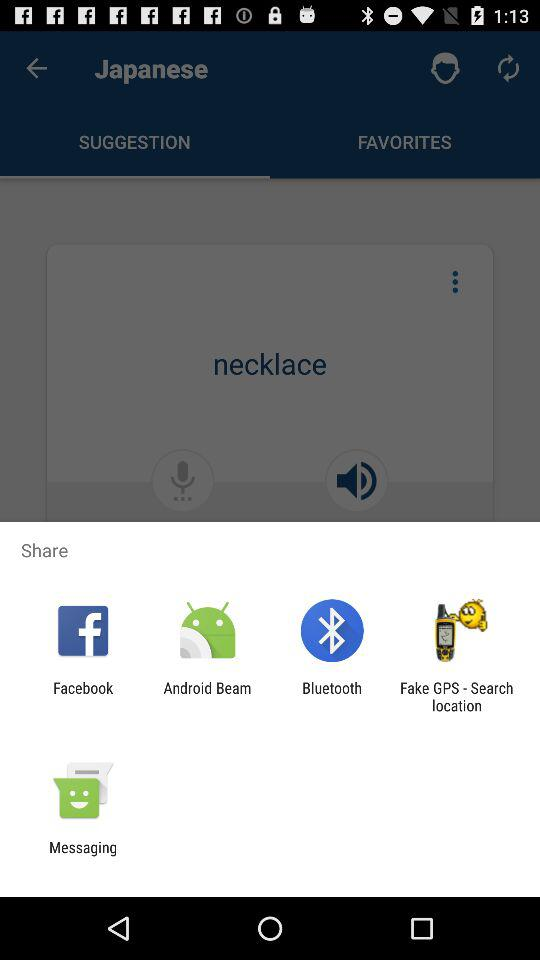Through what applications can content be shared? The applications are "Facebook", "Android Beam", "Bluetooth", "Fake GPS-Search location" and "Messaging". 